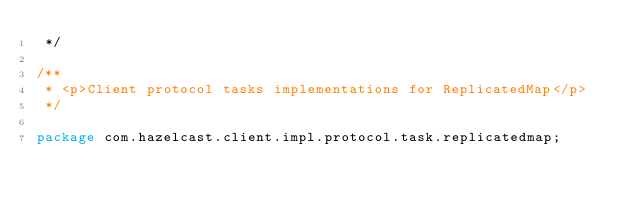<code> <loc_0><loc_0><loc_500><loc_500><_Java_> */

/**
 * <p>Client protocol tasks implementations for ReplicatedMap</p>
 */

package com.hazelcast.client.impl.protocol.task.replicatedmap;



</code> 